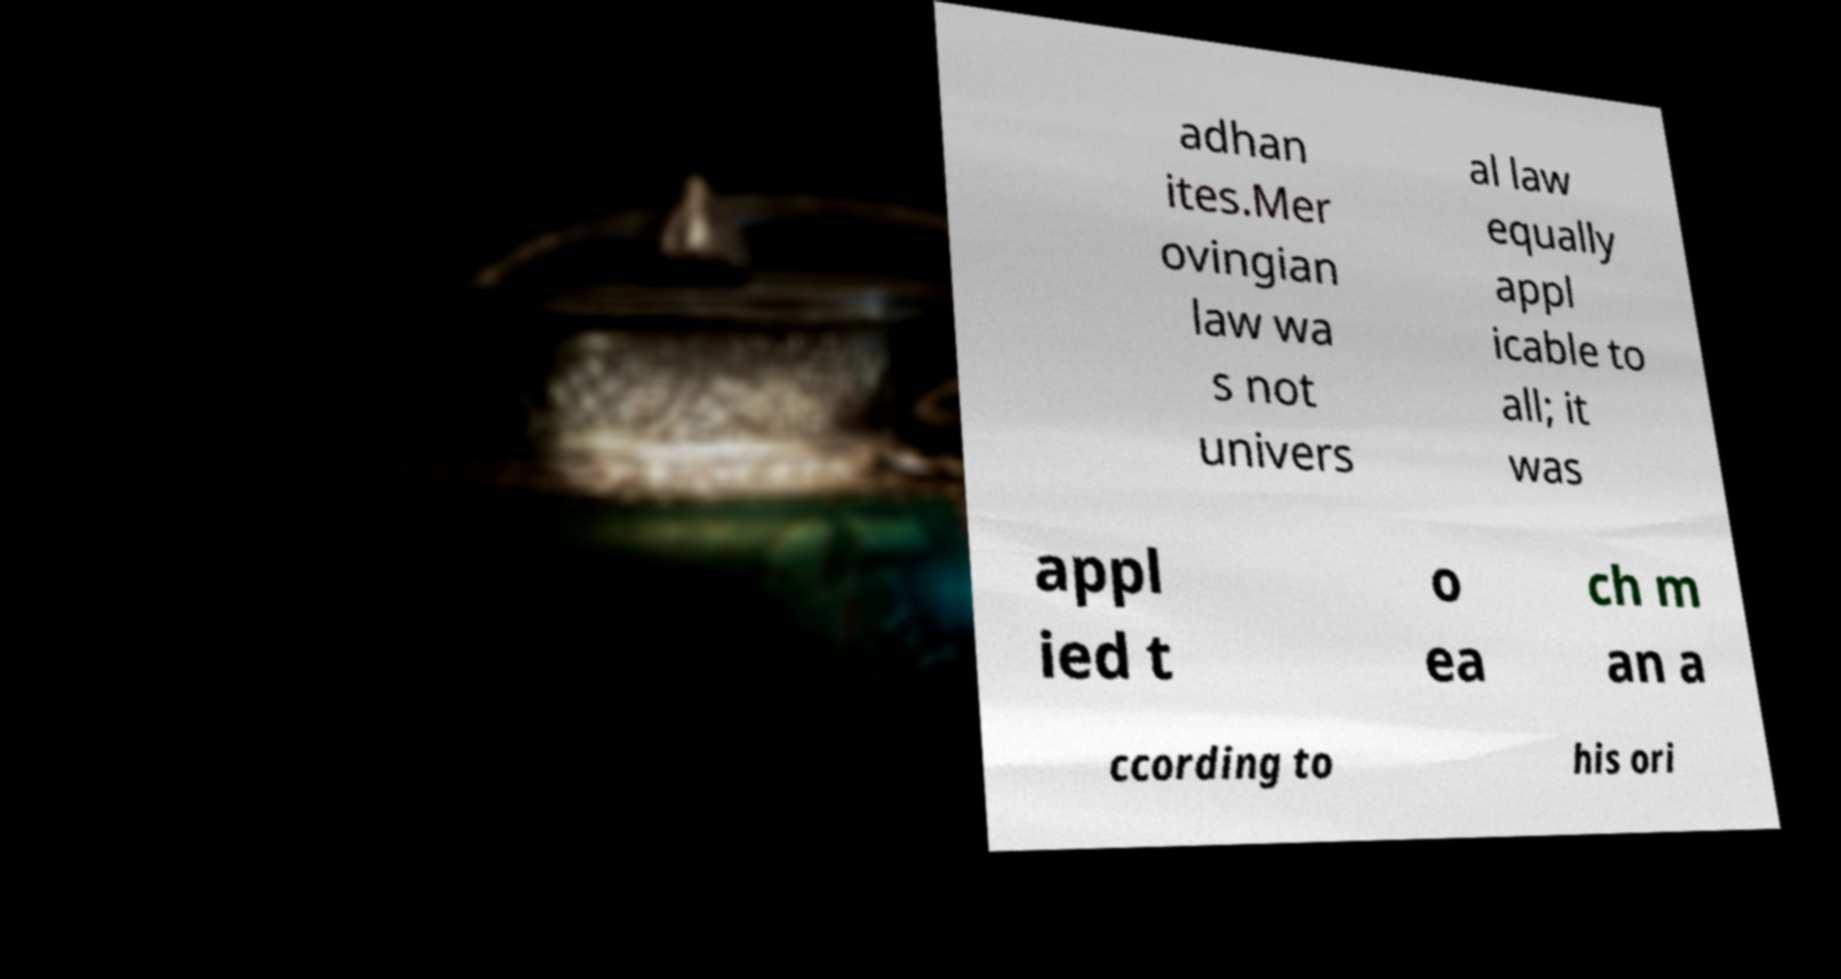Please identify and transcribe the text found in this image. adhan ites.Mer ovingian law wa s not univers al law equally appl icable to all; it was appl ied t o ea ch m an a ccording to his ori 